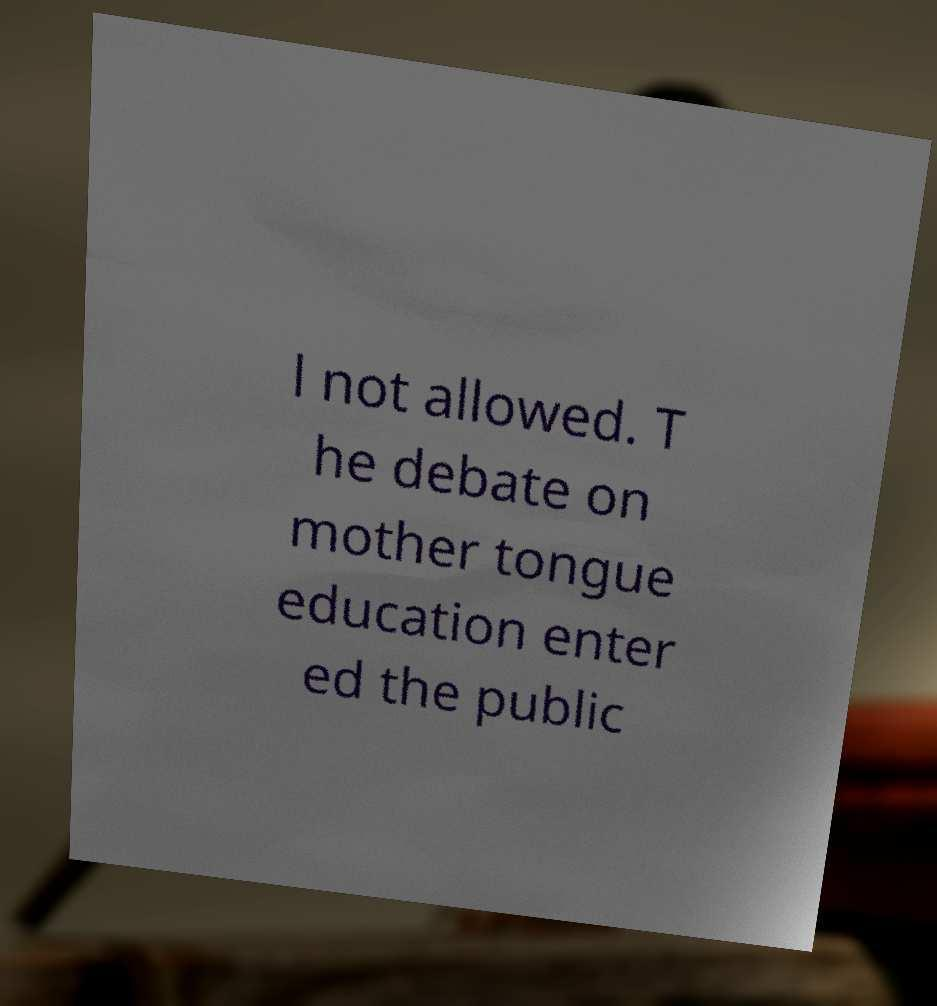Could you extract and type out the text from this image? l not allowed. T he debate on mother tongue education enter ed the public 